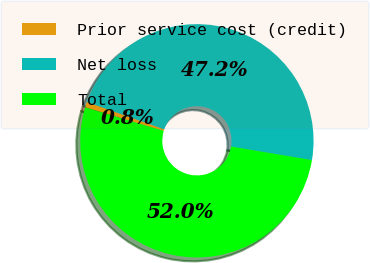Convert chart to OTSL. <chart><loc_0><loc_0><loc_500><loc_500><pie_chart><fcel>Prior service cost (credit)<fcel>Net loss<fcel>Total<nl><fcel>0.77%<fcel>47.25%<fcel>51.98%<nl></chart> 